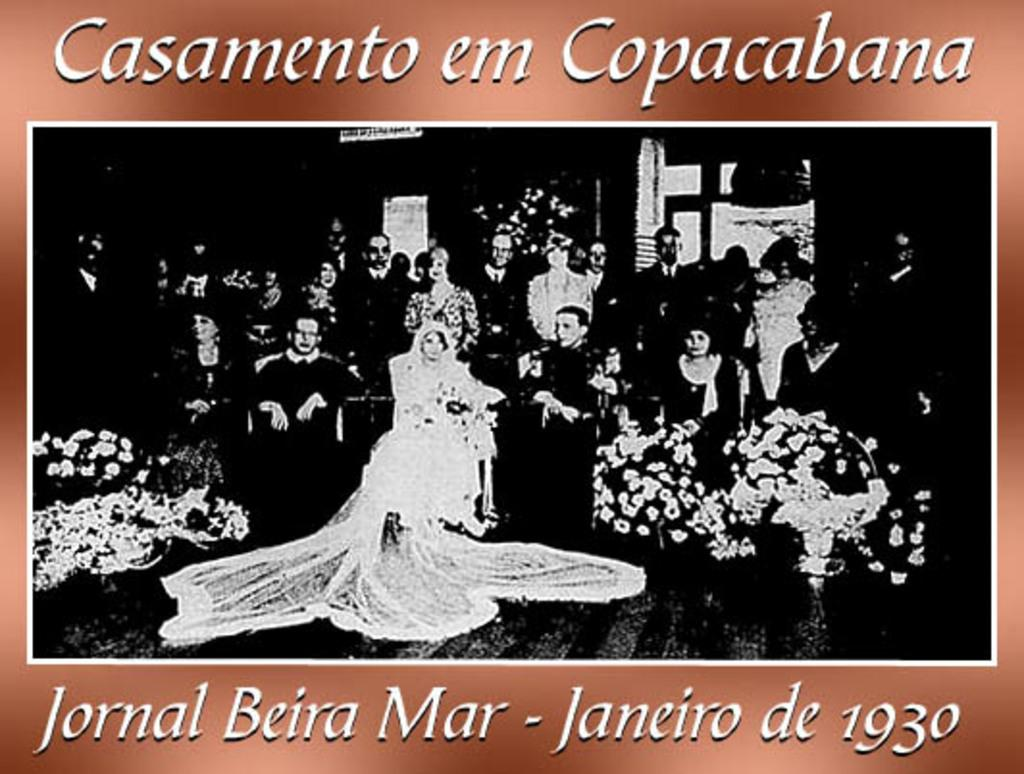What is featured in the image? There is a poster in the image. What can be seen on the poster? The poster contains people and text. What type of polish is being applied to the poster in the image? There is no polish being applied to the poster in the image. Is there a volcano erupting in the background of the poster? There is no volcano present in the image, as it only features a poster with people and text. 